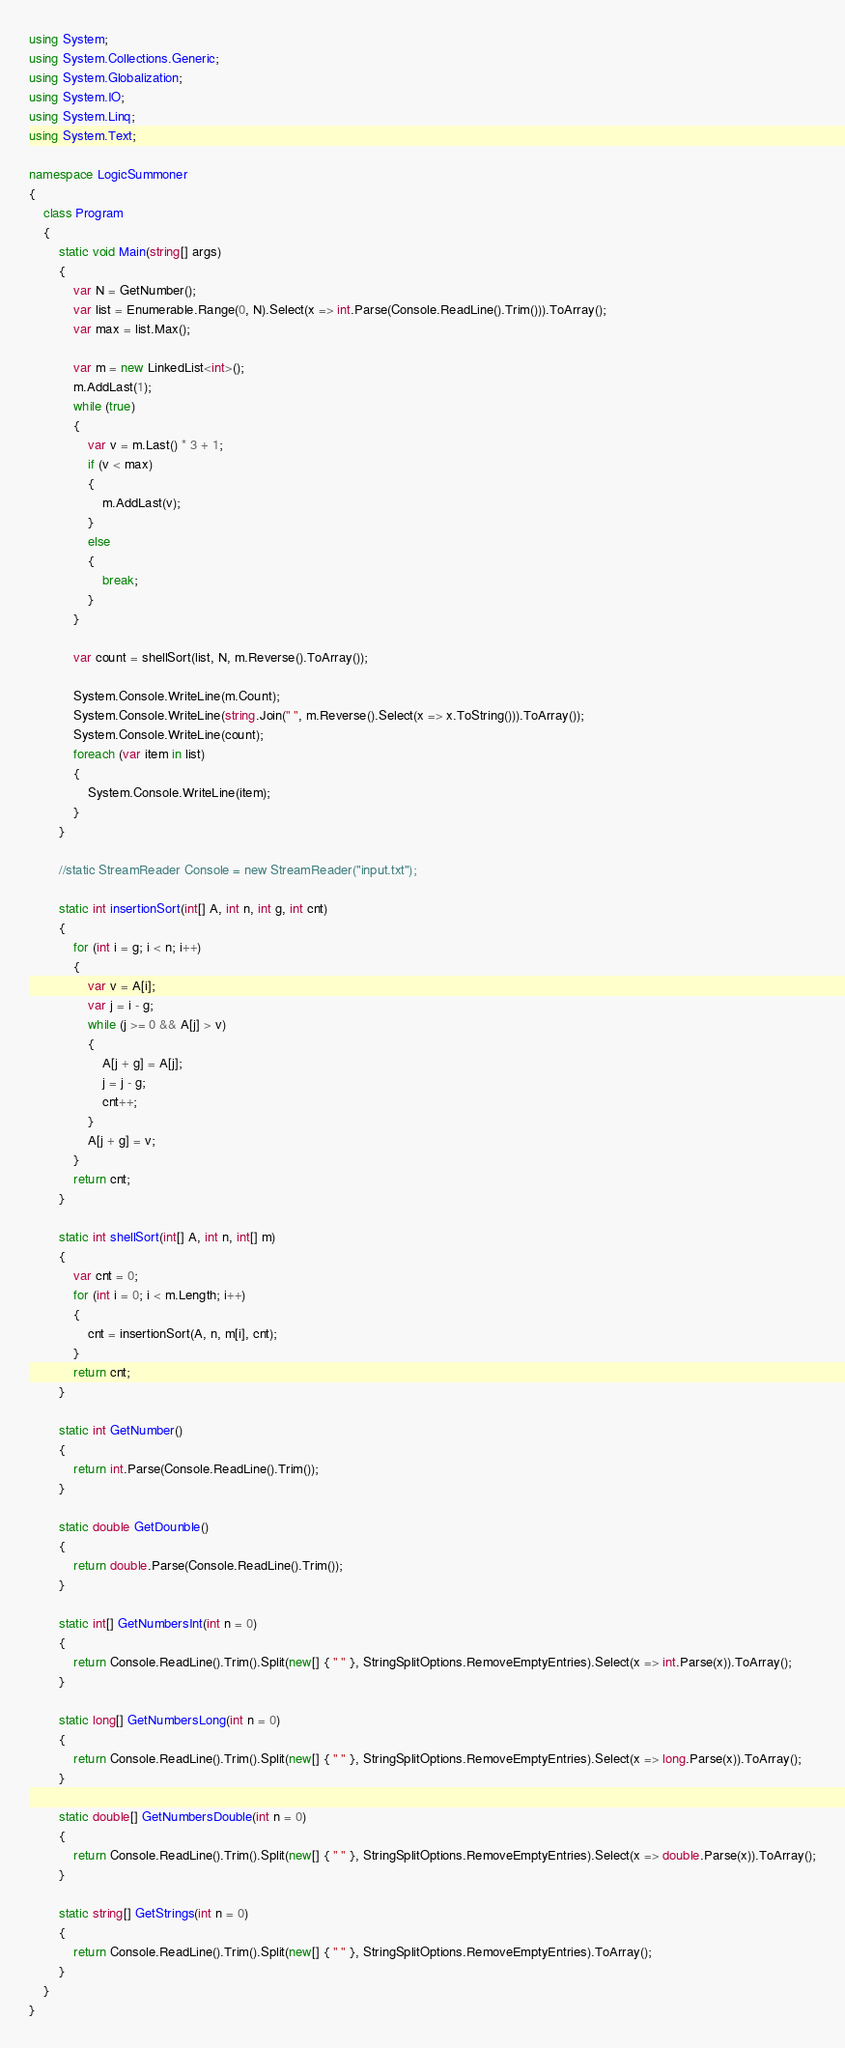<code> <loc_0><loc_0><loc_500><loc_500><_C#_>using System;
using System.Collections.Generic;
using System.Globalization;
using System.IO;
using System.Linq;
using System.Text;

namespace LogicSummoner
{
    class Program
    {
        static void Main(string[] args)
        {
            var N = GetNumber();
            var list = Enumerable.Range(0, N).Select(x => int.Parse(Console.ReadLine().Trim())).ToArray();
            var max = list.Max();

            var m = new LinkedList<int>();
            m.AddLast(1);
            while (true)
            {
                var v = m.Last() * 3 + 1;
                if (v < max)
                {
                    m.AddLast(v);
                }
                else
                {
                    break;
                }
            }

            var count = shellSort(list, N, m.Reverse().ToArray());

            System.Console.WriteLine(m.Count);
            System.Console.WriteLine(string.Join(" ", m.Reverse().Select(x => x.ToString())).ToArray());
            System.Console.WriteLine(count);
            foreach (var item in list)
            {
                System.Console.WriteLine(item);
            }
        }

        //static StreamReader Console = new StreamReader("input.txt");

        static int insertionSort(int[] A, int n, int g, int cnt)
        {
            for (int i = g; i < n; i++)
            {
                var v = A[i];
                var j = i - g;
                while (j >= 0 && A[j] > v)
                {
                    A[j + g] = A[j];
                    j = j - g;
                    cnt++;
                }
                A[j + g] = v;
            }
            return cnt;
        }

        static int shellSort(int[] A, int n, int[] m)
        {
            var cnt = 0;
            for (int i = 0; i < m.Length; i++)
            {
                cnt = insertionSort(A, n, m[i], cnt);
            }
            return cnt;
        }

        static int GetNumber()
        {
            return int.Parse(Console.ReadLine().Trim());
        }

        static double GetDounble()
        {
            return double.Parse(Console.ReadLine().Trim());
        }

        static int[] GetNumbersInt(int n = 0)
        {
            return Console.ReadLine().Trim().Split(new[] { " " }, StringSplitOptions.RemoveEmptyEntries).Select(x => int.Parse(x)).ToArray();
        }

        static long[] GetNumbersLong(int n = 0)
        {
            return Console.ReadLine().Trim().Split(new[] { " " }, StringSplitOptions.RemoveEmptyEntries).Select(x => long.Parse(x)).ToArray();
        }

        static double[] GetNumbersDouble(int n = 0)
        {
            return Console.ReadLine().Trim().Split(new[] { " " }, StringSplitOptions.RemoveEmptyEntries).Select(x => double.Parse(x)).ToArray();
        }

        static string[] GetStrings(int n = 0)
        {
            return Console.ReadLine().Trim().Split(new[] { " " }, StringSplitOptions.RemoveEmptyEntries).ToArray();
        }
    }
}</code> 